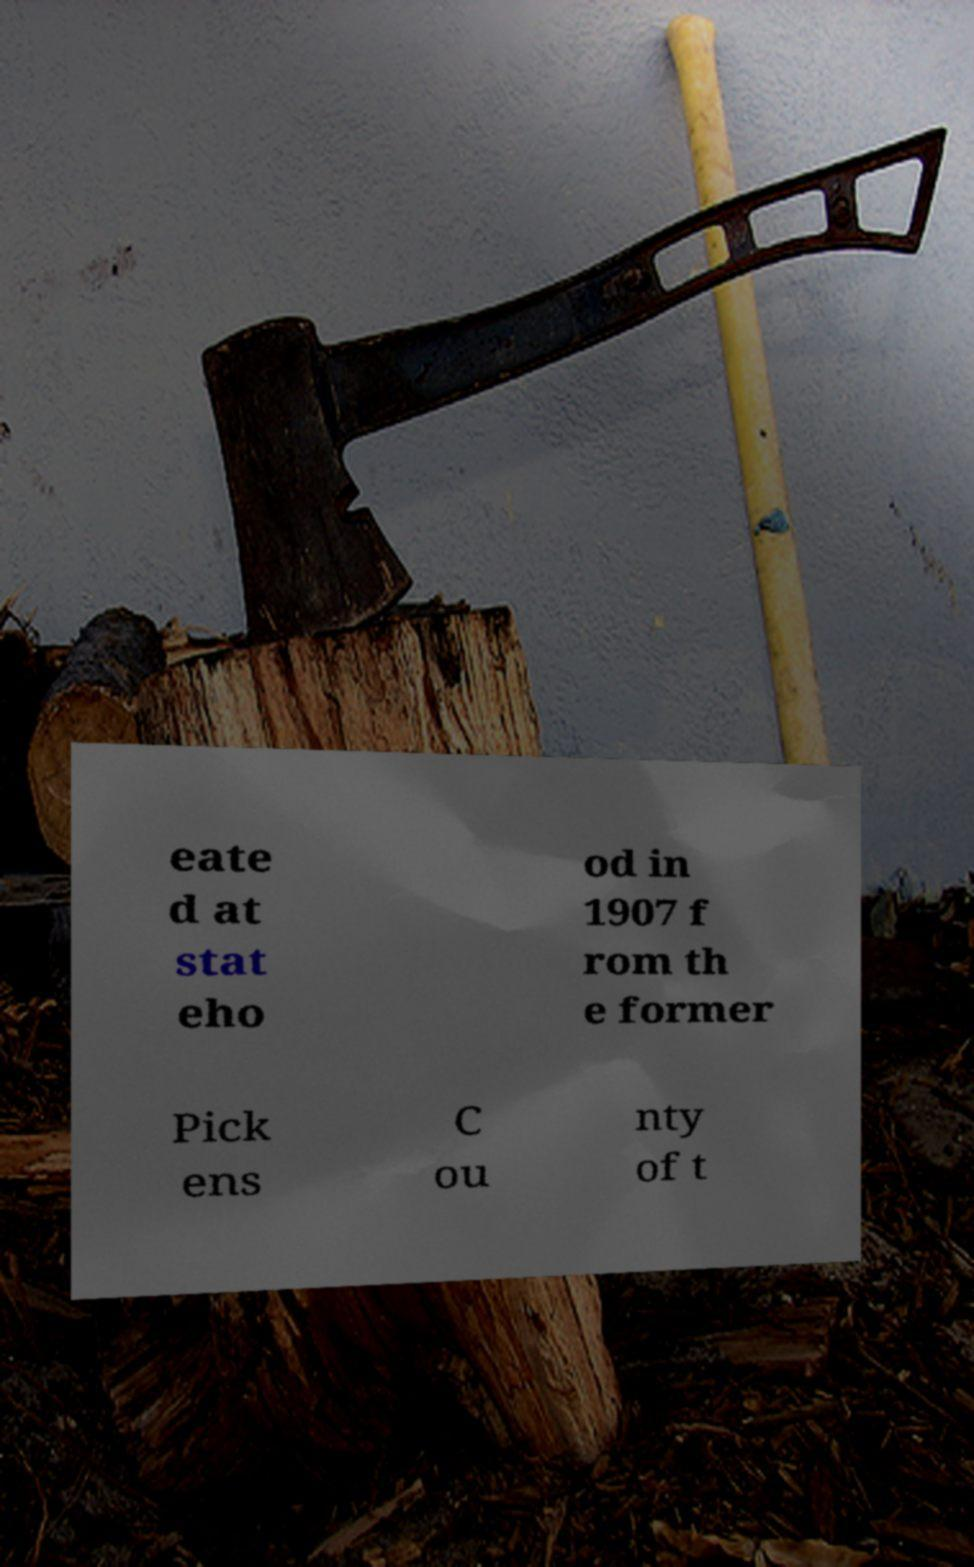Can you read and provide the text displayed in the image?This photo seems to have some interesting text. Can you extract and type it out for me? eate d at stat eho od in 1907 f rom th e former Pick ens C ou nty of t 